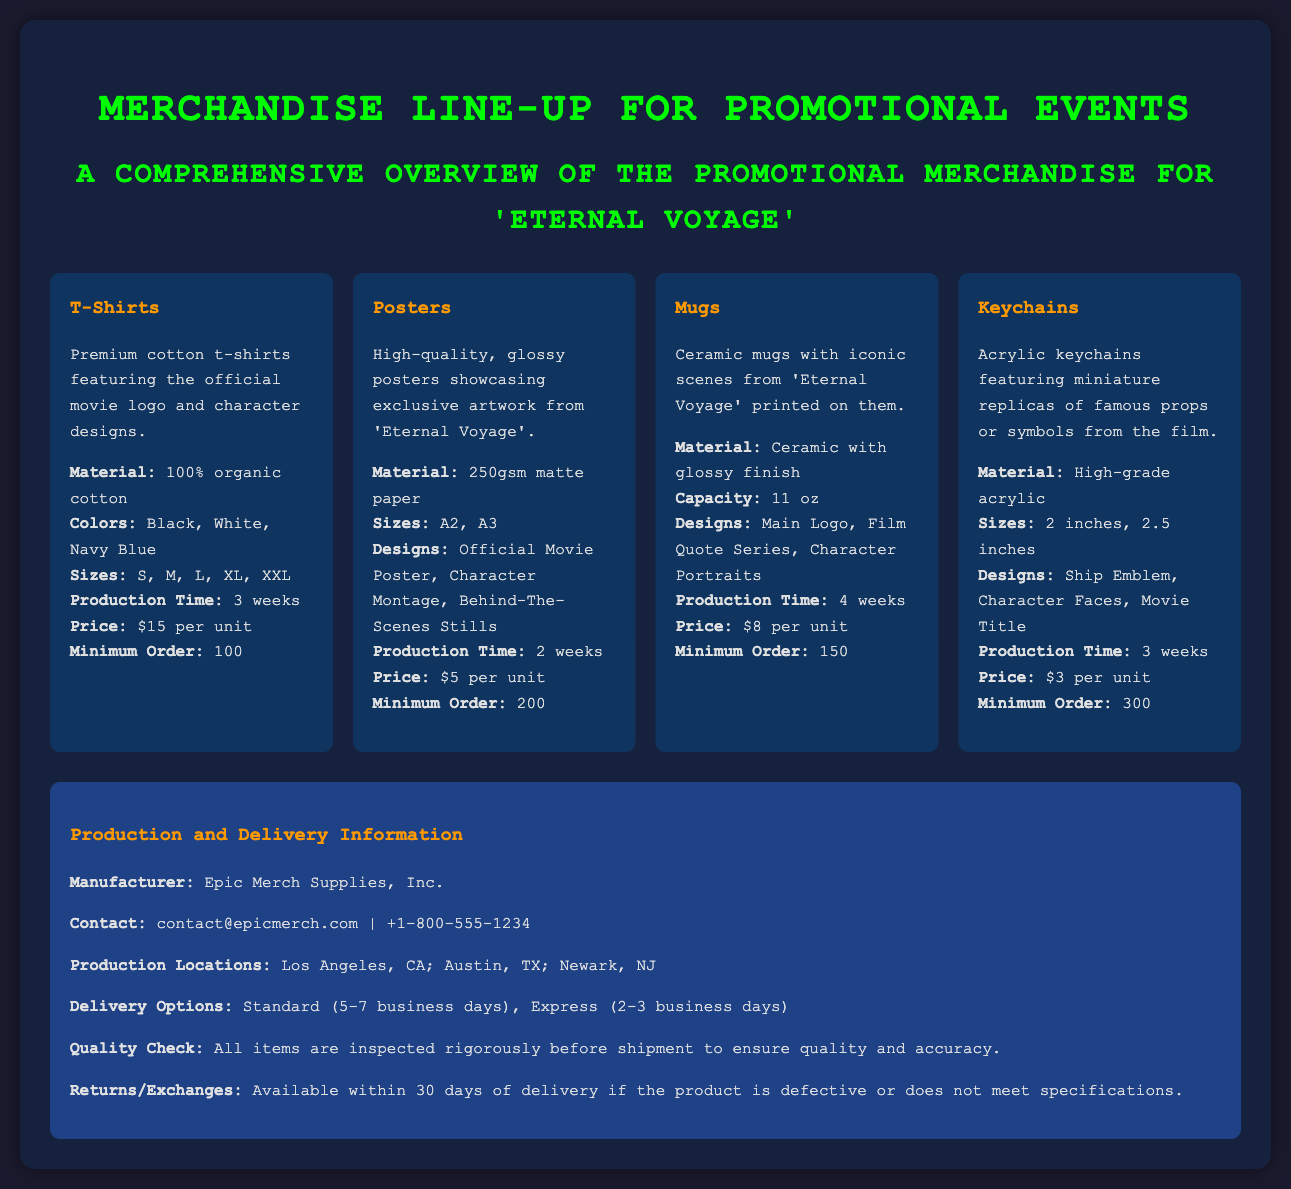What are the available colors for T-Shirts? The available colors for T-Shirts are listed in the product card under the T-Shirts section.
Answer: Black, White, Navy Blue What is the minimum order quantity for Posters? The minimum order quantity is specified in the Posters product card.
Answer: 200 What is the production time for Mugs? The production time for Mugs is mentioned in the Mugs product card.
Answer: 4 weeks What materials are used for Keychains? The materials used for Keychains can be found in the Keychains product card.
Answer: High-grade acrylic How many designs are available for Mugs? The available designs for Mugs can be counted from its product card entries.
Answer: 3 What is the price per unit for T-Shirts? The price per unit is specified in the T-Shirts product card.
Answer: $15 per unit Who is the manufacturer listed in the production information? The manufacturer is stated in the production and delivery information section.
Answer: Epic Merch Supplies, Inc What are the delivery options mentioned? The delivery options are provided in the production and delivery information section and can be summarized briefly.
Answer: Standard, Express What is the capacity of the Ceramic mugs? The capacity is specified in the Mugs product card.
Answer: 11 oz 